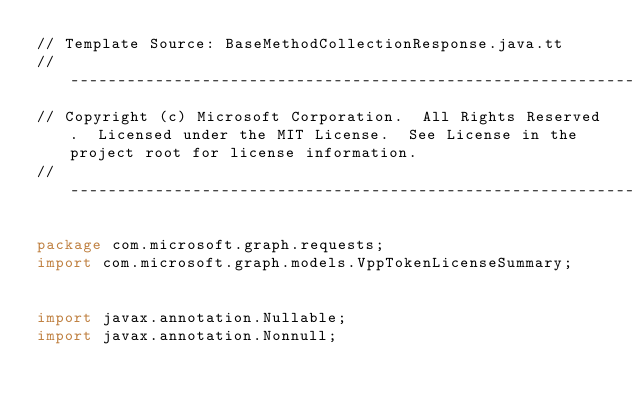<code> <loc_0><loc_0><loc_500><loc_500><_Java_>// Template Source: BaseMethodCollectionResponse.java.tt
// ------------------------------------------------------------------------------
// Copyright (c) Microsoft Corporation.  All Rights Reserved.  Licensed under the MIT License.  See License in the project root for license information.
// ------------------------------------------------------------------------------

package com.microsoft.graph.requests;
import com.microsoft.graph.models.VppTokenLicenseSummary;


import javax.annotation.Nullable;
import javax.annotation.Nonnull;</code> 